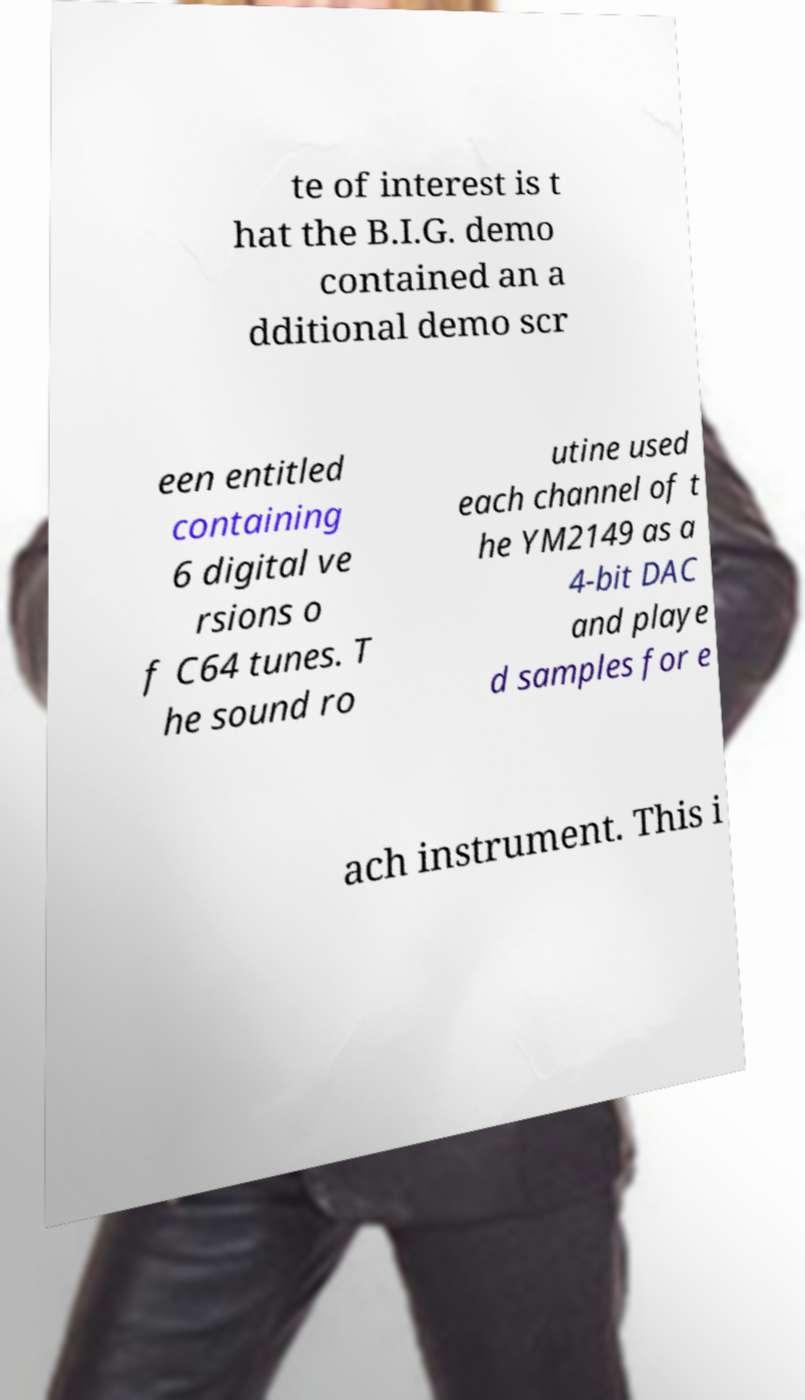Please identify and transcribe the text found in this image. te of interest is t hat the B.I.G. demo contained an a dditional demo scr een entitled containing 6 digital ve rsions o f C64 tunes. T he sound ro utine used each channel of t he YM2149 as a 4-bit DAC and playe d samples for e ach instrument. This i 